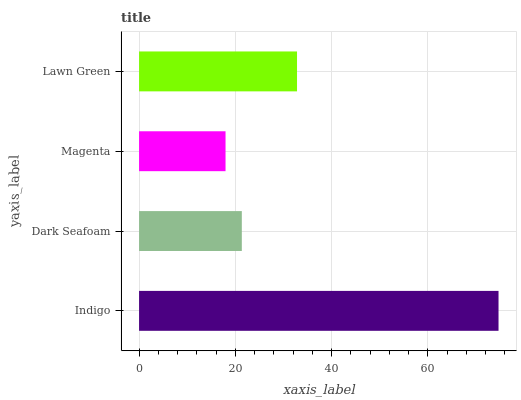Is Magenta the minimum?
Answer yes or no. Yes. Is Indigo the maximum?
Answer yes or no. Yes. Is Dark Seafoam the minimum?
Answer yes or no. No. Is Dark Seafoam the maximum?
Answer yes or no. No. Is Indigo greater than Dark Seafoam?
Answer yes or no. Yes. Is Dark Seafoam less than Indigo?
Answer yes or no. Yes. Is Dark Seafoam greater than Indigo?
Answer yes or no. No. Is Indigo less than Dark Seafoam?
Answer yes or no. No. Is Lawn Green the high median?
Answer yes or no. Yes. Is Dark Seafoam the low median?
Answer yes or no. Yes. Is Magenta the high median?
Answer yes or no. No. Is Indigo the low median?
Answer yes or no. No. 